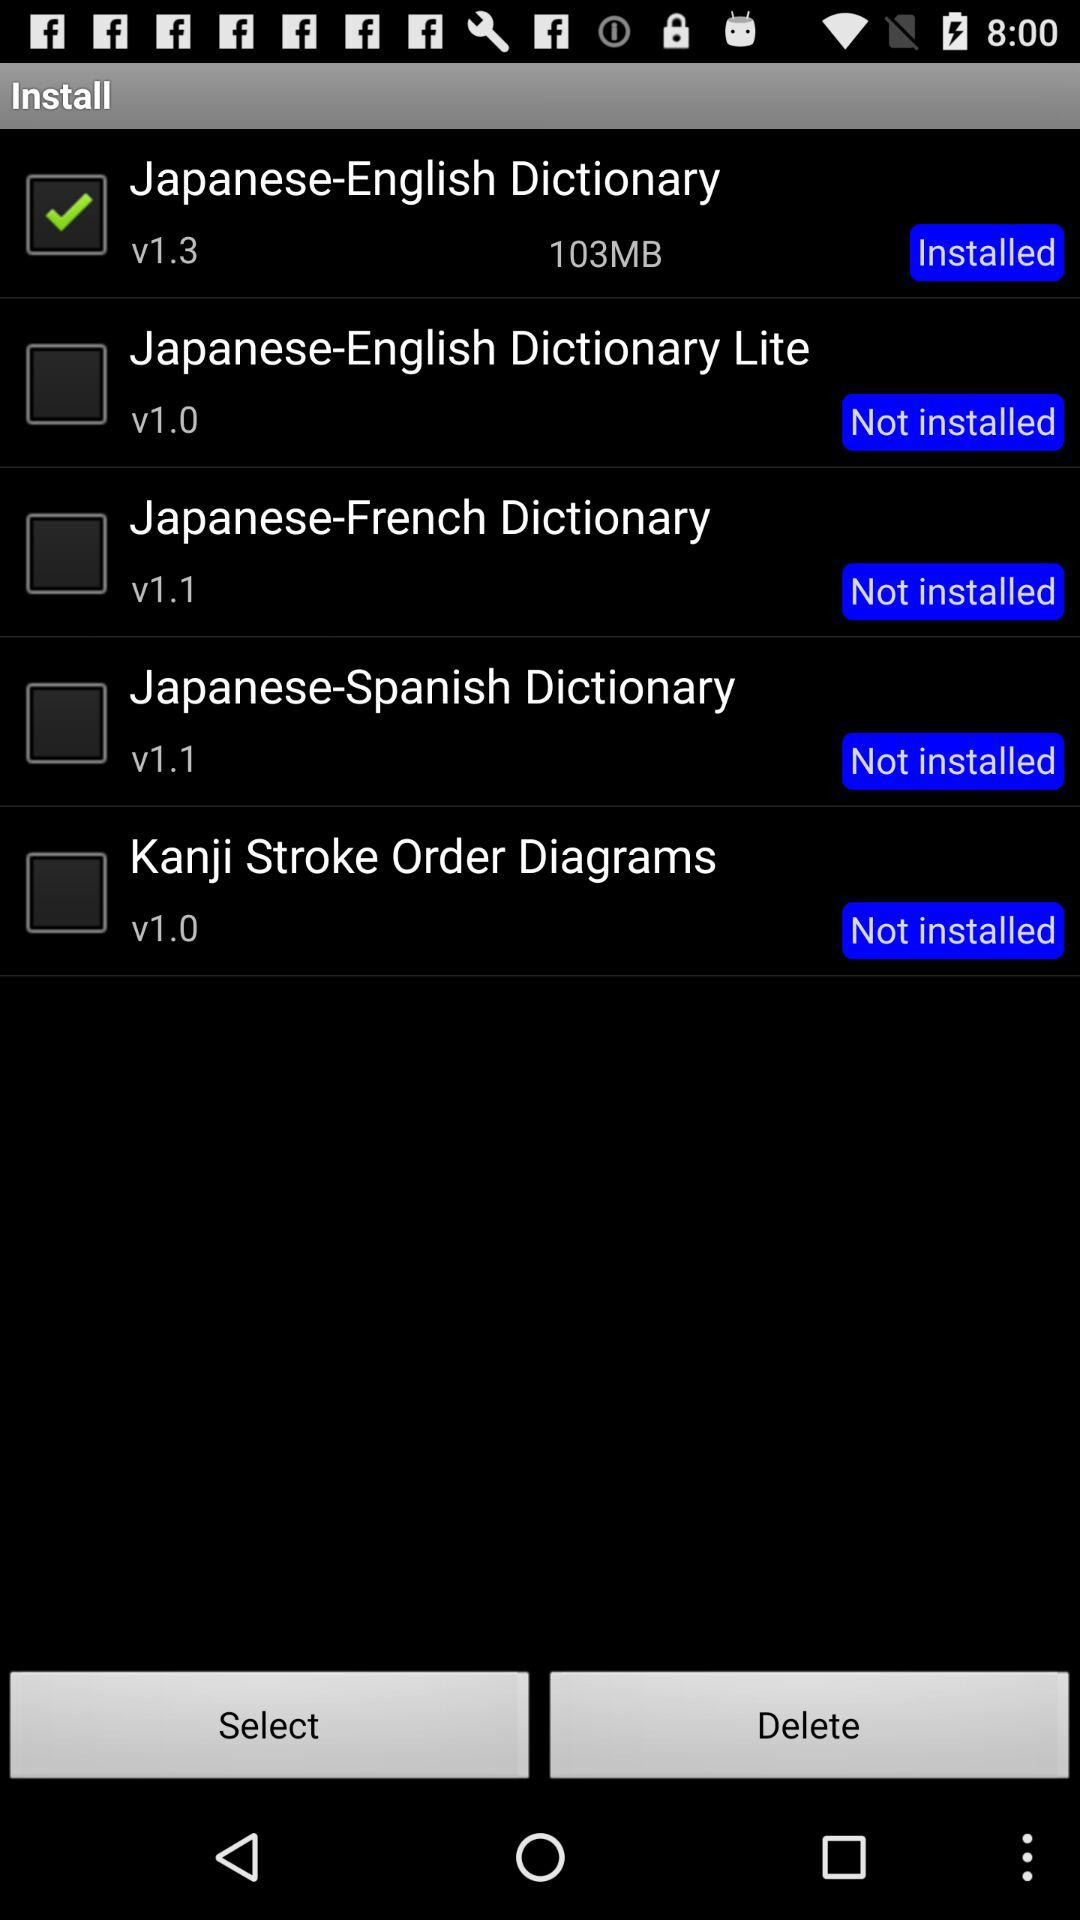How many dictionaries have a version number of 1.1?
Answer the question using a single word or phrase. 2 